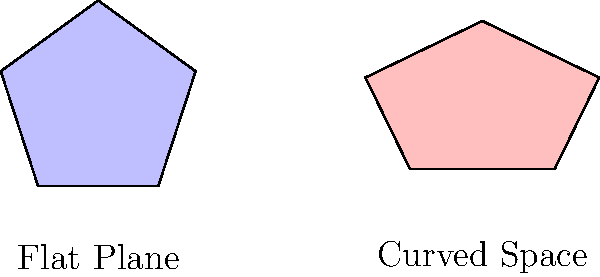As a motorsport rider, you encounter various racing surfaces. Consider a regular pentagon representing a racing circuit on two different surfaces: a flat plane and a curved space. If the area of the pentagon on the flat plane is 100 square units, what would be its approximate area on the curved space shown, assuming the curvature causes a 20% increase in the length of each side? Let's approach this step-by-step:

1) For a regular pentagon on a flat plane, the area $A$ is given by:
   $$A = \frac{1}{4}\sqrt{25+10\sqrt{5}}s^2$$
   where $s$ is the side length.

2) We're told the area on the flat plane is 100 square units. So:
   $$100 = \frac{1}{4}\sqrt{25+10\sqrt{5}}s^2$$

3) On the curved space, each side is 20% longer. If we call the new side length $s'$:
   $$s' = 1.2s$$

4) The area formula for the curved space pentagon would be similar, but with $s'$ instead of $s$:
   $$A' = \frac{1}{4}\sqrt{25+10\sqrt{5}}(s')^2$$

5) Substituting $s' = 1.2s$:
   $$A' = \frac{1}{4}\sqrt{25+10\sqrt{5}}(1.2s)^2 = 1.44 \cdot \frac{1}{4}\sqrt{25+10\sqrt{5}}s^2$$

6) We know that $\frac{1}{4}\sqrt{25+10\sqrt{5}}s^2 = 100$ from step 2, so:
   $$A' = 1.44 \cdot 100 = 144$$

Therefore, the area of the pentagon on the curved space would be approximately 144 square units.
Answer: 144 square units 